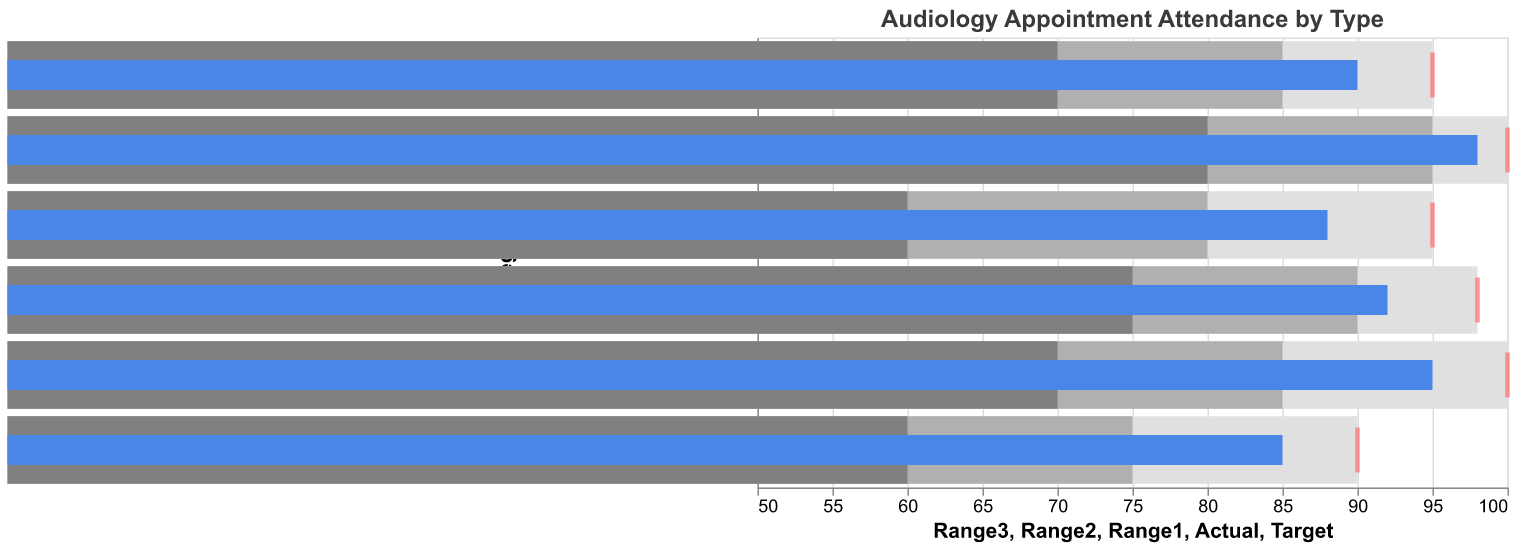What is the title of the bullet chart? The title is mentioned at the top of the chart; it provides a brief description of what the chart is about.
Answer: Audiology Appointment Attendance by Type What color represents the 'Actual' percentage of attendance in the chart? The 'Actual' percentage of attendance is depicted using a specific color in the chart to distinguish it from other metrics.
Answer: Blue What is the 'Target' attendance percentage for Follow-up Checkups? The Target attendance rate for each appointment type is indicated by a tick mark along the x-axis. For Follow-up Checkups, locate the specific tick.
Answer: 95 Which type of appointment has the highest 'Actual' attendance percentage? Compare the 'Actual' attendance values for all appointment types; the highest one stands out in the data.
Answer: Cochlear Implant Mapping Which appointment type has an 'Actual' percentage of attendance greater than its 'Range3' lower bound but less than the 'Target'? Identify which actual values are above the 'Range3' lower bound and then see if they are below the Target mark.
Answer: Follow-up Checkups What's the difference between the 'Target' and 'Actual' attendance percentages for Speech Therapy? Subtract the 'Actual' percentage from the 'Target' percentage for the Speech Therapy data point to find the difference.
Answer: 5 How many appointment types have an 'Actual' attendance percentage that meets or exceeds their 'Target'? Count the number of categories where the 'Actual' attendance is equal to or greater than the 'Target' attendance values.
Answer: 2 Which appointment type has the widest gap between 'Range1' and 'Range3'? Calculate the gaps ('Range3' - 'Range1') for each appointment type and find the largest one.
Answer: Cochlear Implant Mapping What is the average 'Actual' attendance percentage across all appointment types? Sum the 'Actual' percentages of all categories and divide by the number of appointment types. Calculation steps: (95 + 88 + 92 + 85 + 98 + 90) / 6 = 90.
Answer: 90 